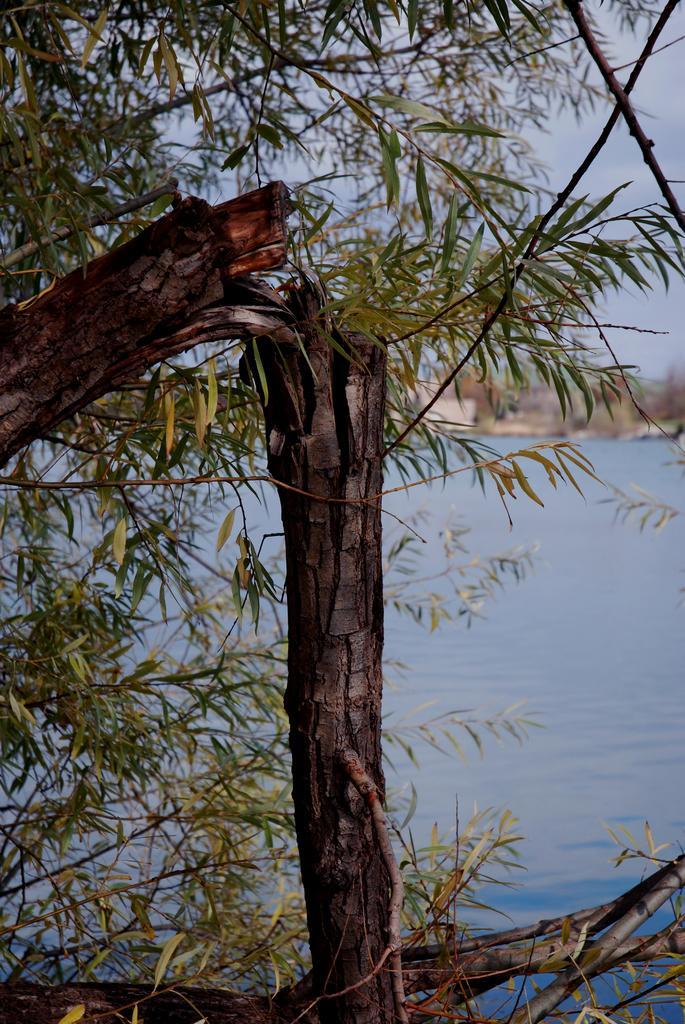How would you summarize this image in a sentence or two? In this image in the foreground there is one tree, and in the background there is a sea and some houses. 